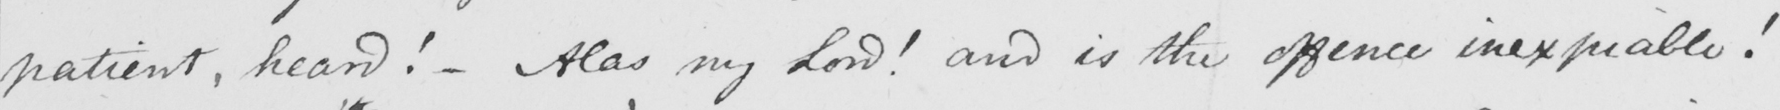What text is written in this handwritten line? patient , heard !   _  Alas , my Lord !  and is the offence inexpiable ! 